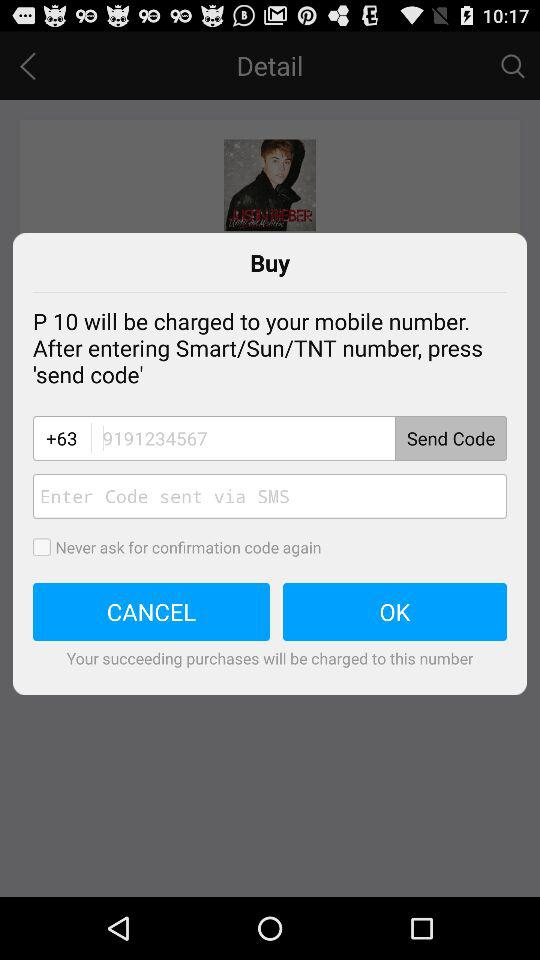What is the country code? The country code is +63. 